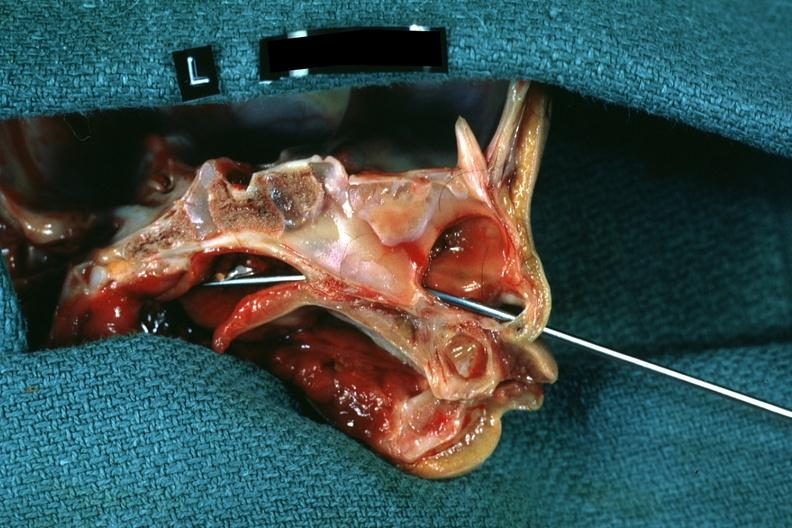what does this image show?
Answer the question using a single word or phrase. Hemisection of nose left side showing patency right side was not patent 